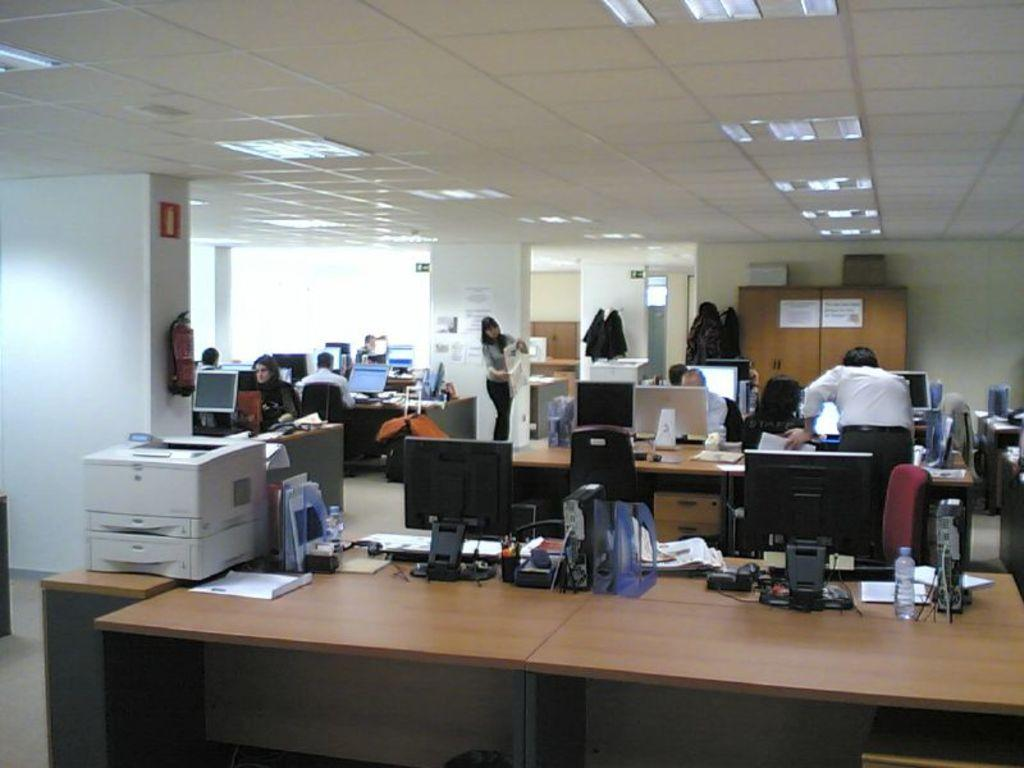Who is present in the image? There are people in the image. What are the people doing in the image? The people are working on an office system. Where is the office system located in the image? The office system is on the floor. What type of milk is being used to clean the office system in the image? There is no milk present in the image, and the office system is not being cleaned. 